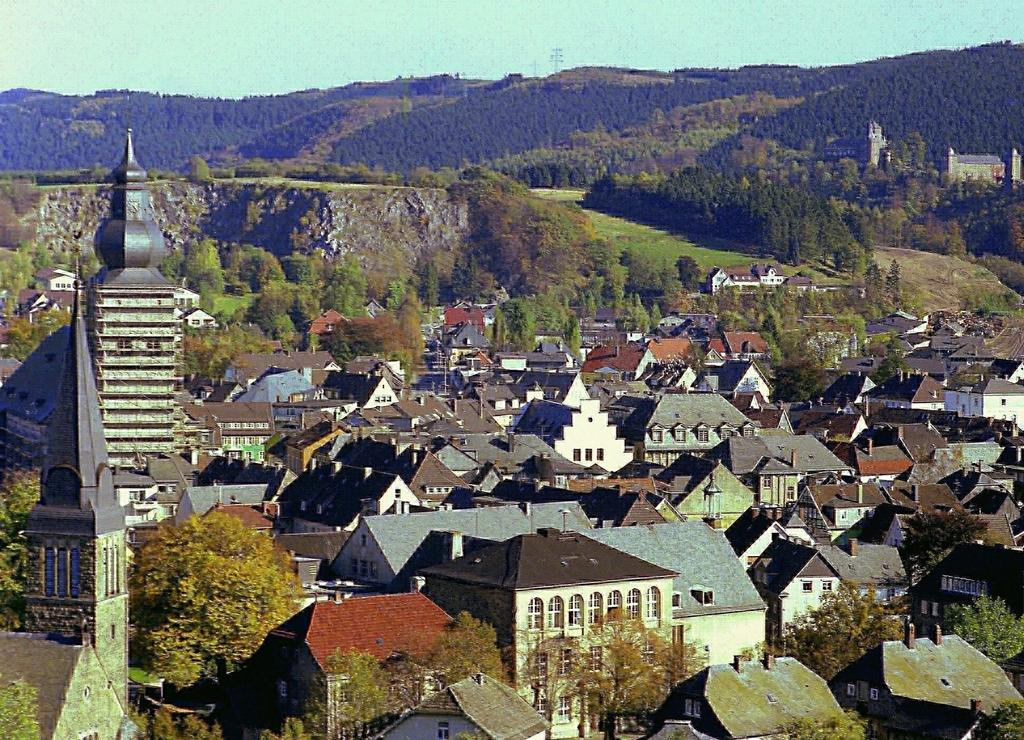What type of natural elements can be seen in the image? There are trees in the image. What type of man-made structures are present in the image? There are buildings in the image. Can you describe the placement of the buildings in the image? The buildings are in the front and background of the image. What is visible in the background of the image? The sky is visible in the background of the image. What hobbies do the women in the image engage in? There are no women present in the image, so it is not possible to determine their hobbies. 